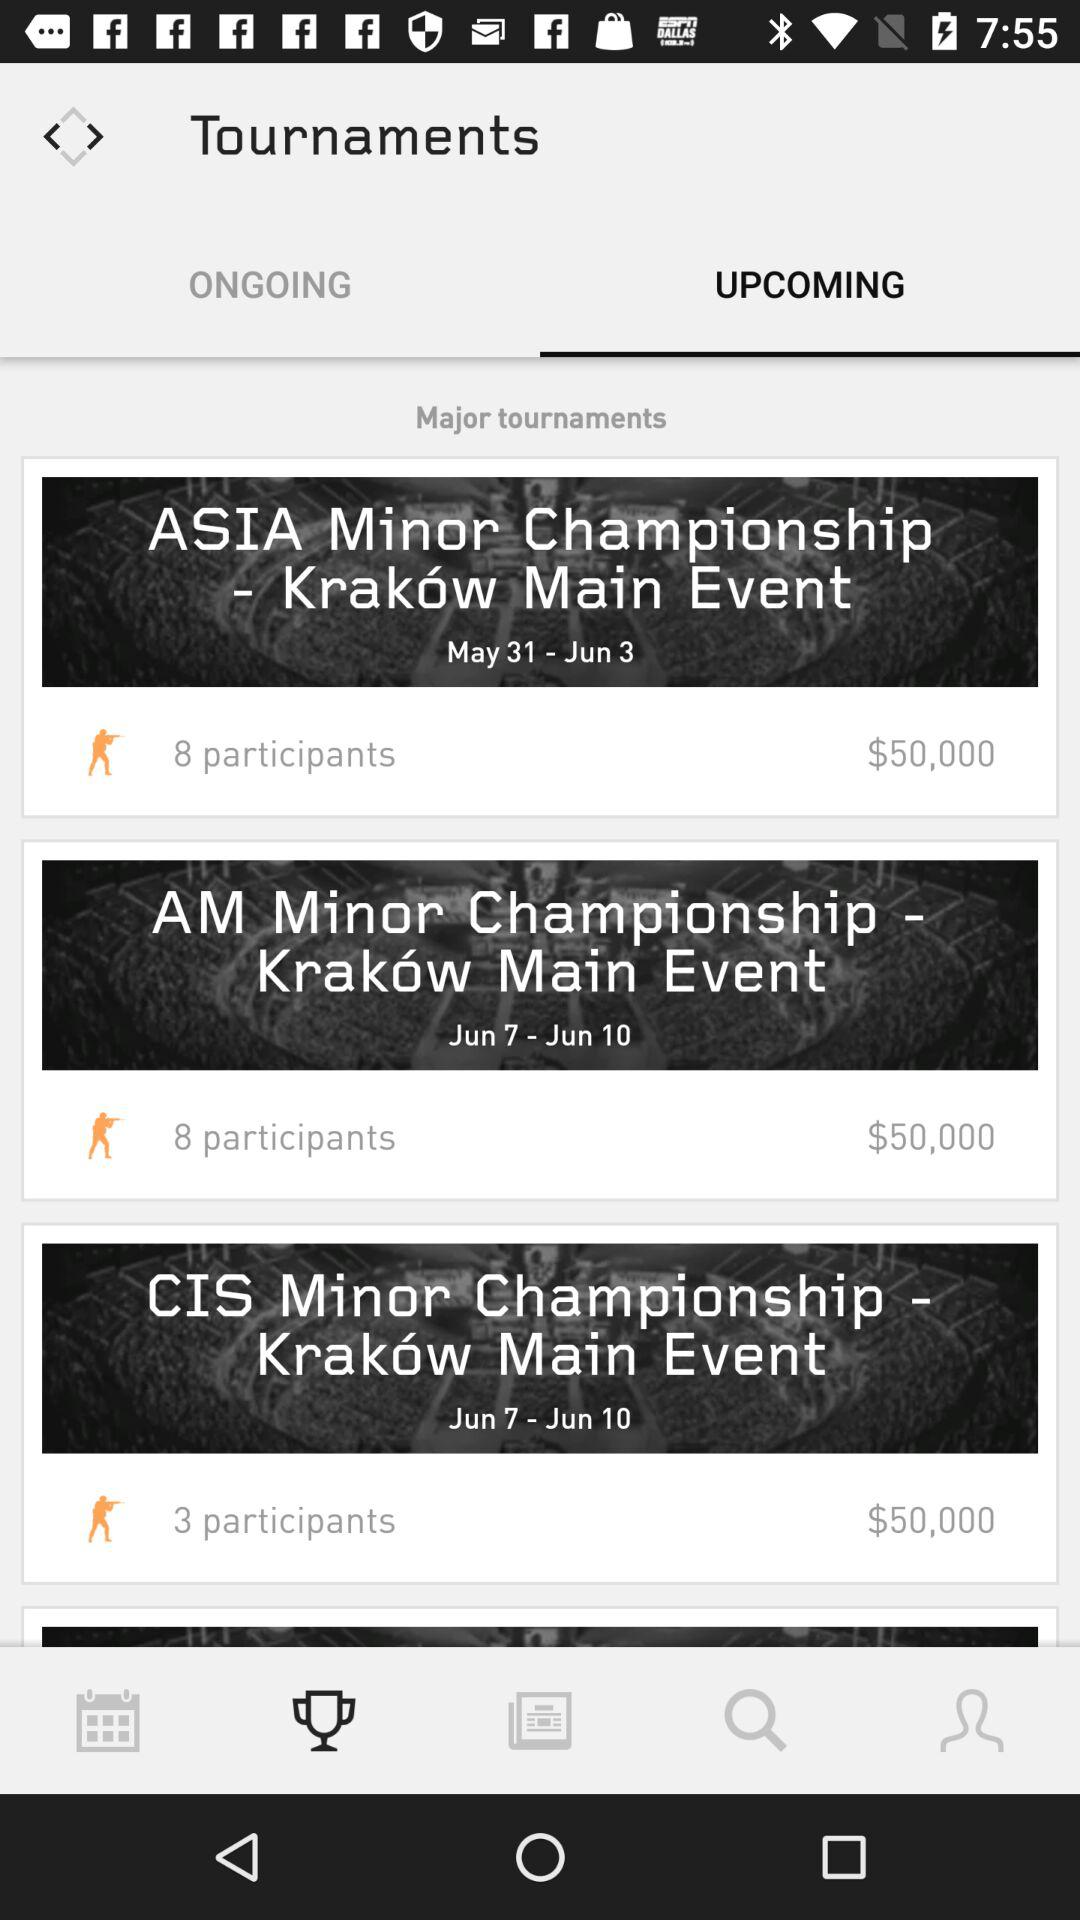Which tab is selected? The selected tab is "UPCOMING". 